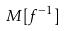<formula> <loc_0><loc_0><loc_500><loc_500>M [ f ^ { - 1 } ]</formula> 